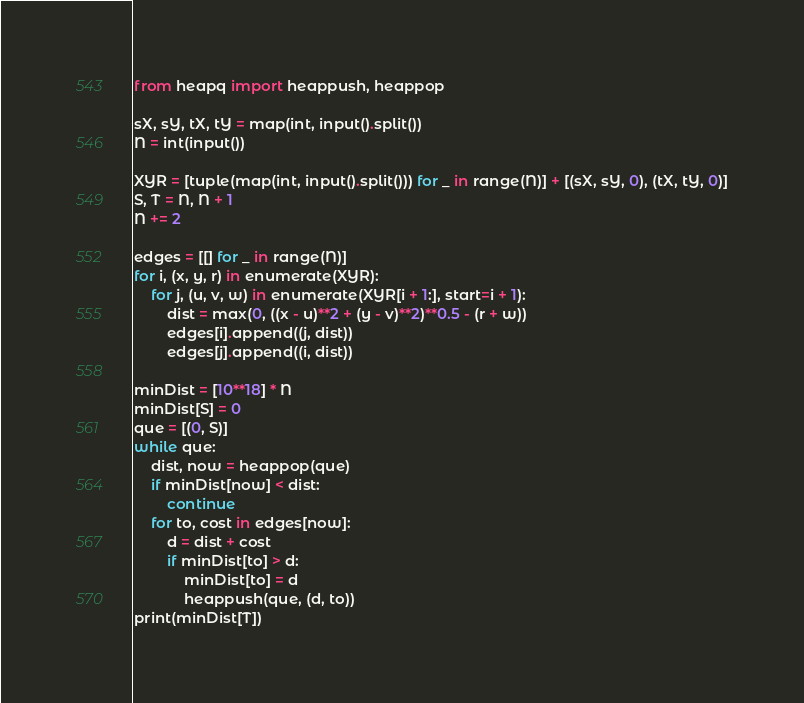<code> <loc_0><loc_0><loc_500><loc_500><_Python_>from heapq import heappush, heappop

sX, sY, tX, tY = map(int, input().split())
N = int(input())

XYR = [tuple(map(int, input().split())) for _ in range(N)] + [(sX, sY, 0), (tX, tY, 0)]
S, T = N, N + 1
N += 2

edges = [[] for _ in range(N)]
for i, (x, y, r) in enumerate(XYR):
    for j, (u, v, w) in enumerate(XYR[i + 1:], start=i + 1):
        dist = max(0, ((x - u)**2 + (y - v)**2)**0.5 - (r + w))
        edges[i].append((j, dist))
        edges[j].append((i, dist))

minDist = [10**18] * N
minDist[S] = 0
que = [(0, S)]
while que:
    dist, now = heappop(que)
    if minDist[now] < dist:
        continue
    for to, cost in edges[now]:
        d = dist + cost
        if minDist[to] > d:
            minDist[to] = d
            heappush(que, (d, to))
print(minDist[T])
</code> 